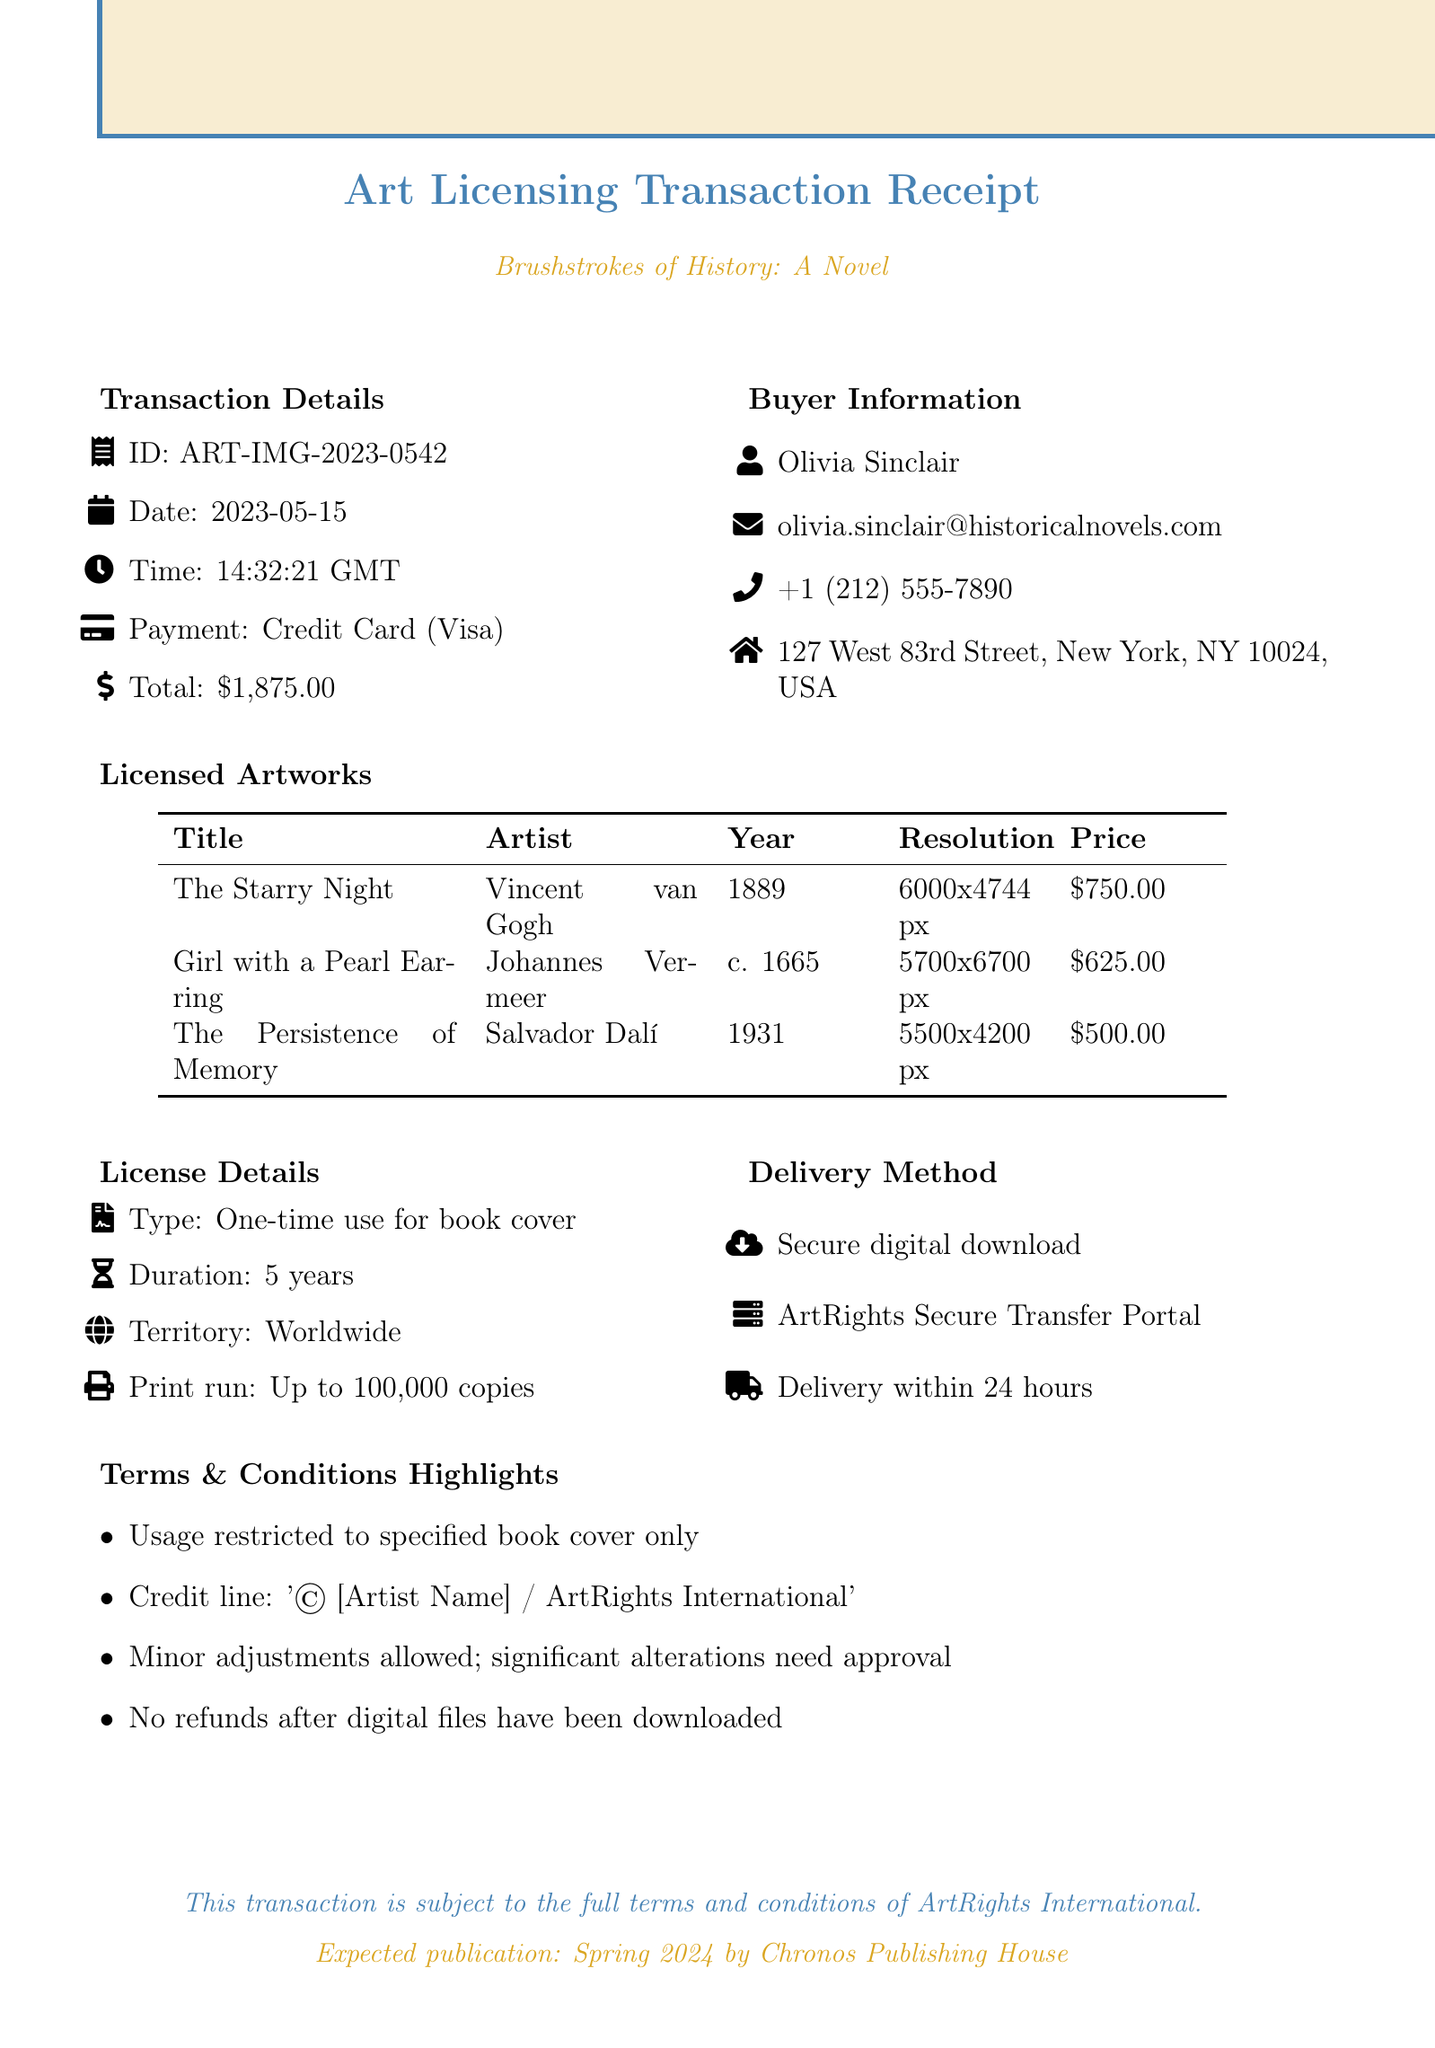What is the transaction ID? The transaction ID is a unique identifier for the specific transaction, which is provided in the document.
Answer: ART-IMG-2023-0542 What is the total amount paid? The total amount paid in the transaction is mentioned clearly at the end of the transaction details section.
Answer: $1,875.00 Who is the contact person for the seller? The contact person for the seller is specified in the seller information section.
Answer: Marcus Rothko What is the license type? The license type indicates how the artwork can be used, and it is specified under license details.
Answer: One-time use for book cover How many copies can be printed? The number of copies that can be printed is outlined in the license details section, expressing limitations on the print run.
Answer: Up to 100,000 copies What is the delivery method? The delivery method describes how the images will be sent to the buyer, provided in the respective section.
Answer: Secure digital download What is the estimated delivery time? The estimated delivery time indicates how soon the buyer can expect to receive the licensed images after payment confirmation.
Answer: Within 24 hours of payment confirmation What is the usage restriction? The usage restriction outlines the limitations on how the purchased images can be used, which is mentioned under terms and conditions.
Answer: Images may only be used for the book cover of the specified historical fiction novel What is the expected publication date? The expected publication date indicates when the book will be released and is provided in the additional notes section.
Answer: Spring 2024 